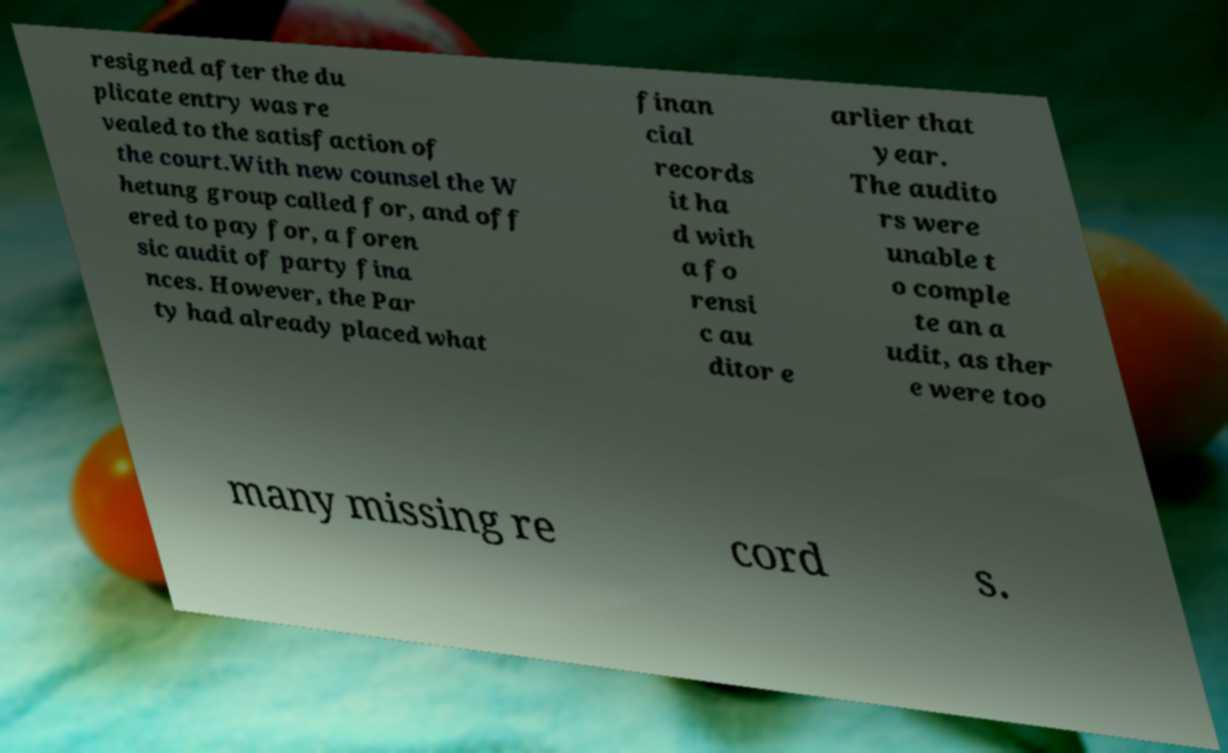Please read and relay the text visible in this image. What does it say? resigned after the du plicate entry was re vealed to the satisfaction of the court.With new counsel the W hetung group called for, and off ered to pay for, a foren sic audit of party fina nces. However, the Par ty had already placed what finan cial records it ha d with a fo rensi c au ditor e arlier that year. The audito rs were unable t o comple te an a udit, as ther e were too many missing re cord s. 